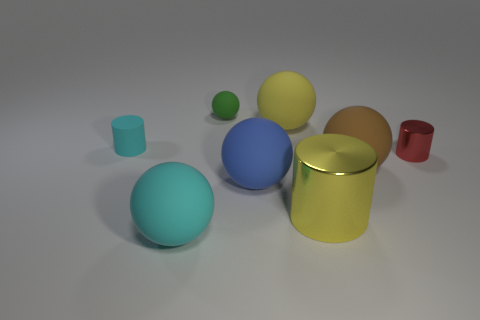Does the small red metallic thing have the same shape as the big yellow shiny thing?
Give a very brief answer. Yes. How many other objects are there of the same size as the yellow rubber sphere?
Offer a terse response. 4. What number of objects are big balls that are behind the large cylinder or big yellow metal cylinders?
Give a very brief answer. 4. What color is the small ball?
Offer a terse response. Green. What is the material of the thing on the left side of the large cyan matte ball?
Offer a very short reply. Rubber. Do the brown matte object and the tiny rubber thing right of the cyan ball have the same shape?
Offer a terse response. Yes. Is the number of big yellow matte spheres greater than the number of large gray metallic things?
Your answer should be very brief. Yes. Is there anything else of the same color as the tiny rubber cylinder?
Make the answer very short. Yes. What is the shape of the small green thing that is the same material as the big blue thing?
Your answer should be very brief. Sphere. There is a large yellow object that is behind the small cyan thing that is behind the big blue sphere; what is its material?
Keep it short and to the point. Rubber. 